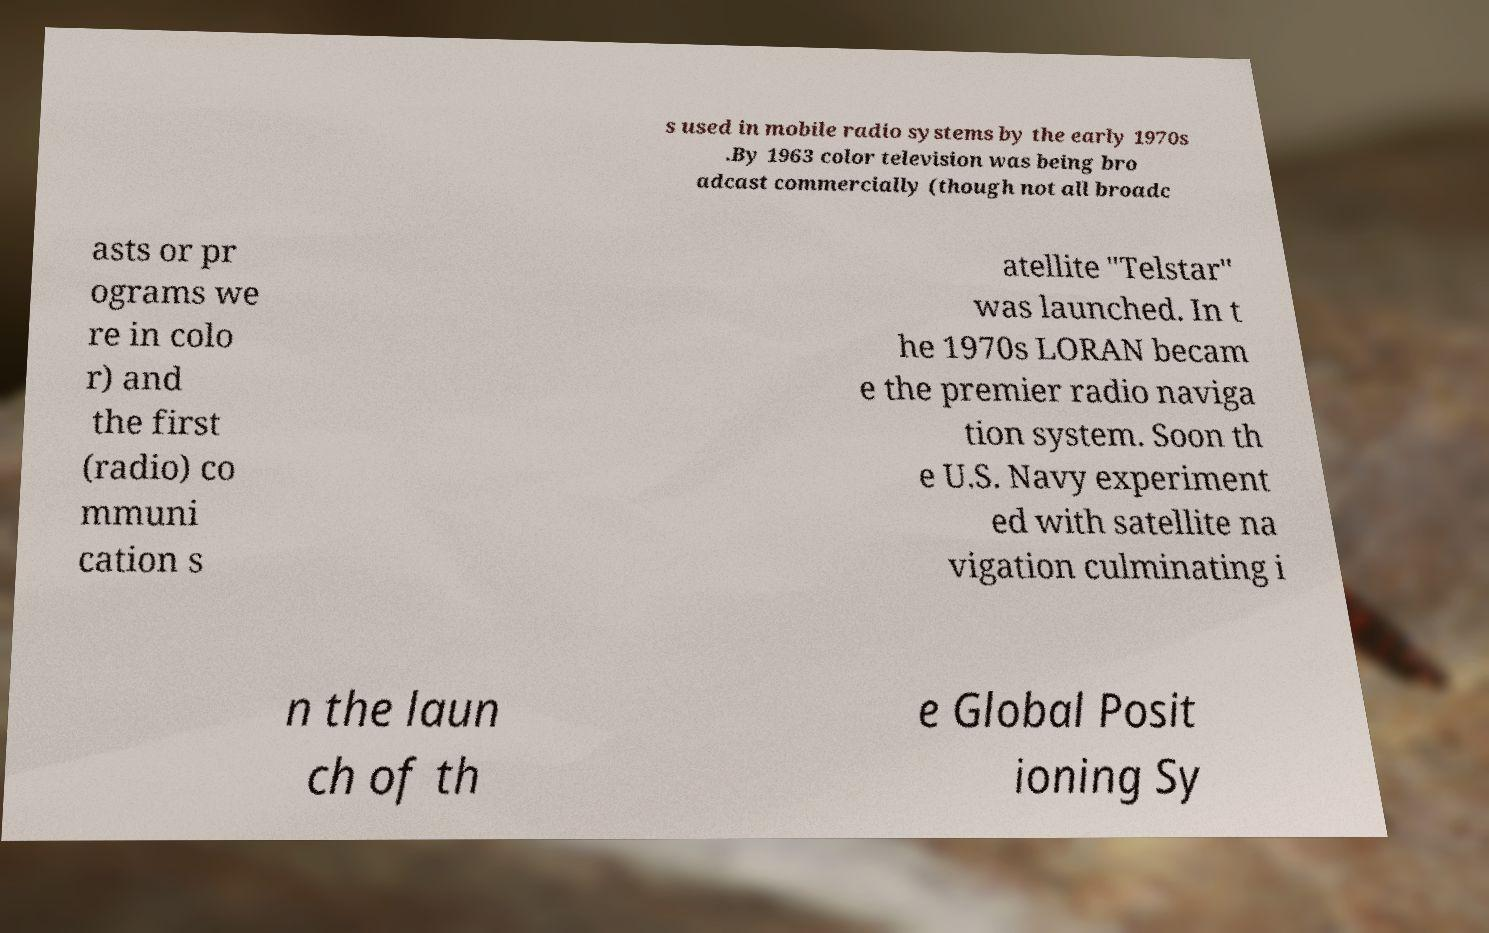Can you read and provide the text displayed in the image?This photo seems to have some interesting text. Can you extract and type it out for me? s used in mobile radio systems by the early 1970s .By 1963 color television was being bro adcast commercially (though not all broadc asts or pr ograms we re in colo r) and the first (radio) co mmuni cation s atellite "Telstar" was launched. In t he 1970s LORAN becam e the premier radio naviga tion system. Soon th e U.S. Navy experiment ed with satellite na vigation culminating i n the laun ch of th e Global Posit ioning Sy 